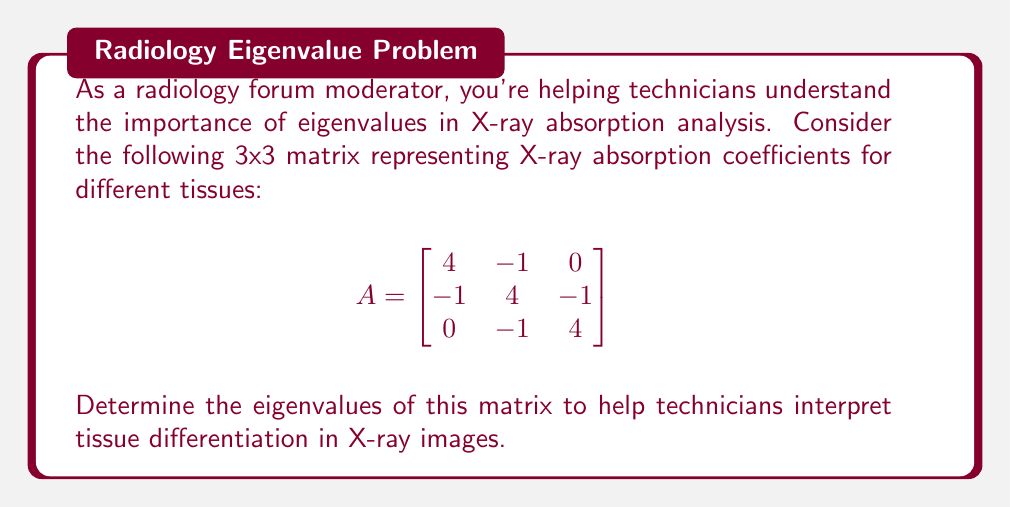Could you help me with this problem? To find the eigenvalues of matrix A, we need to solve the characteristic equation:

$$\det(A - \lambda I) = 0$$

where $\lambda$ represents the eigenvalues and $I$ is the 3x3 identity matrix.

Step 1: Set up the characteristic equation
$$\det\begin{bmatrix}
4-\lambda & -1 & 0 \\
-1 & 4-\lambda & -1 \\
0 & -1 & 4-\lambda
\end{bmatrix} = 0$$

Step 2: Calculate the determinant
$$(4-\lambda)[(4-\lambda)(4-\lambda) - 1] - (-1)[(-1)(4-\lambda) - 0] = 0$$

Step 3: Expand the equation
$$(4-\lambda)[(16-8\lambda+\lambda^2) - 1] + (4-\lambda) = 0$$
$$(4-\lambda)(15-8\lambda+\lambda^2) + (4-\lambda) = 0$$
$$60 - 32\lambda + 4\lambda^2 - 15\lambda + 8\lambda^2 - \lambda^3 + 4 - \lambda = 0$$

Step 4: Simplify
$$-\lambda^3 + 12\lambda^2 - 48\lambda + 64 = 0$$

Step 5: Factor the equation
$$-(\lambda - 4)(\lambda^2 - 8\lambda + 16) = 0$$
$$-(\lambda - 4)(\lambda - 4)^2 = 0$$

Step 6: Solve for $\lambda$
$\lambda = 4$ (with algebraic multiplicity 3)

The eigenvalues represent the principal directions of X-ray absorption in the tissue, with higher values indicating stronger absorption. In this case, all eigenvalues are equal, suggesting uniform absorption characteristics across different tissue orientations.
Answer: The eigenvalue of the matrix is $\lambda = 4$ with algebraic multiplicity 3. 